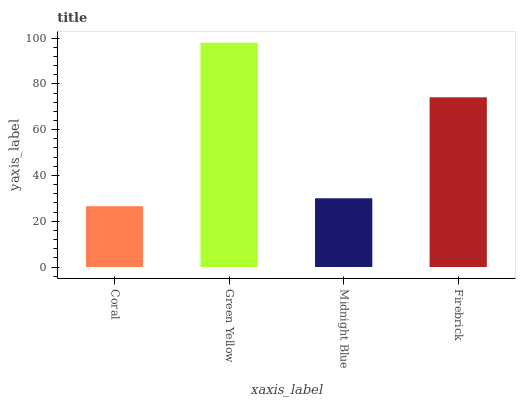Is Coral the minimum?
Answer yes or no. Yes. Is Green Yellow the maximum?
Answer yes or no. Yes. Is Midnight Blue the minimum?
Answer yes or no. No. Is Midnight Blue the maximum?
Answer yes or no. No. Is Green Yellow greater than Midnight Blue?
Answer yes or no. Yes. Is Midnight Blue less than Green Yellow?
Answer yes or no. Yes. Is Midnight Blue greater than Green Yellow?
Answer yes or no. No. Is Green Yellow less than Midnight Blue?
Answer yes or no. No. Is Firebrick the high median?
Answer yes or no. Yes. Is Midnight Blue the low median?
Answer yes or no. Yes. Is Midnight Blue the high median?
Answer yes or no. No. Is Coral the low median?
Answer yes or no. No. 